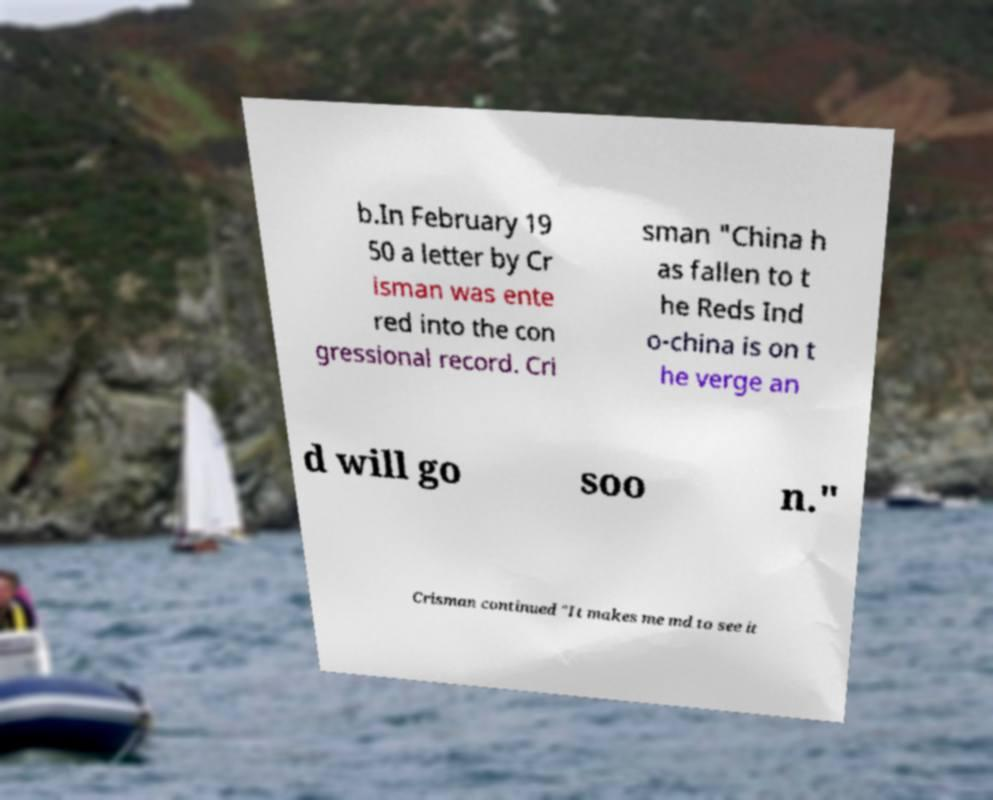For documentation purposes, I need the text within this image transcribed. Could you provide that? b.In February 19 50 a letter by Cr isman was ente red into the con gressional record. Cri sman "China h as fallen to t he Reds Ind o-china is on t he verge an d will go soo n." Crisman continued "It makes me md to see it 